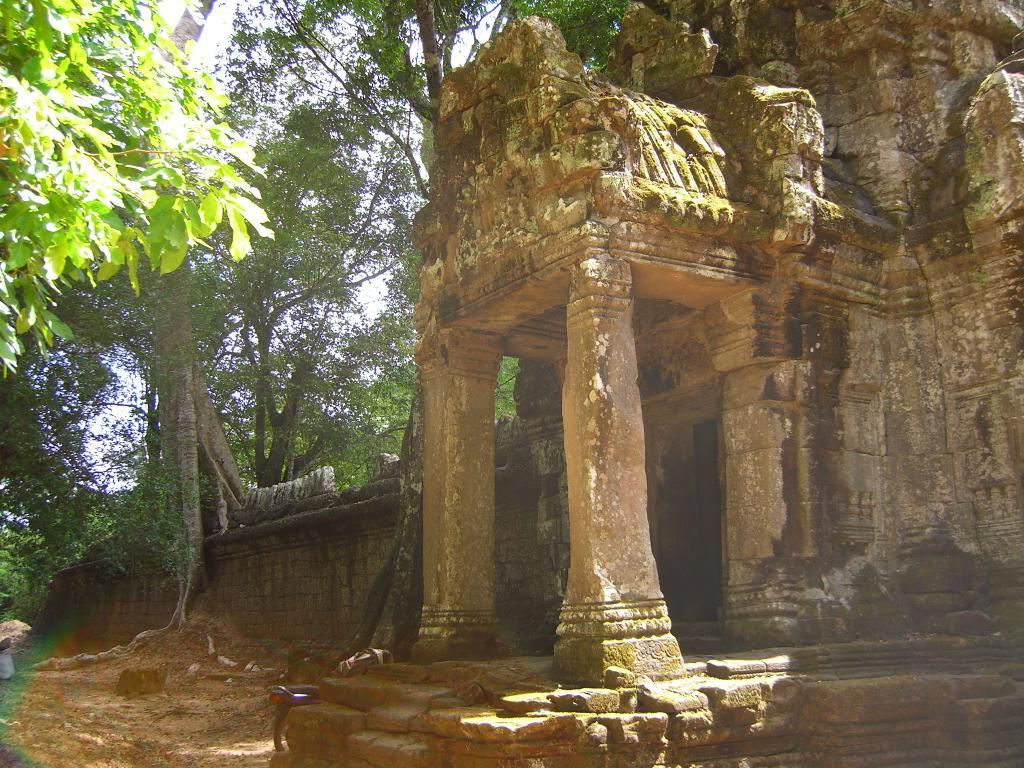What type of structure is located on the right side of the image? There is a stone temple on the right side of the image. What is beside the temple in the middle of the image? There is a bike beside the temple in the middle of the image. What can be seen in the background of the image? There are many trees in the background of the image. What is the terrain like in the image? The land is of mud. What type of bean is growing near the temple in the image? There is no bean plant or bean visible in the image. What type of animal can be seen taking a trip near the temple in the image? There are no animals or trips depicted in the image; it features a stone temple, a bike, trees, and muddy land. 